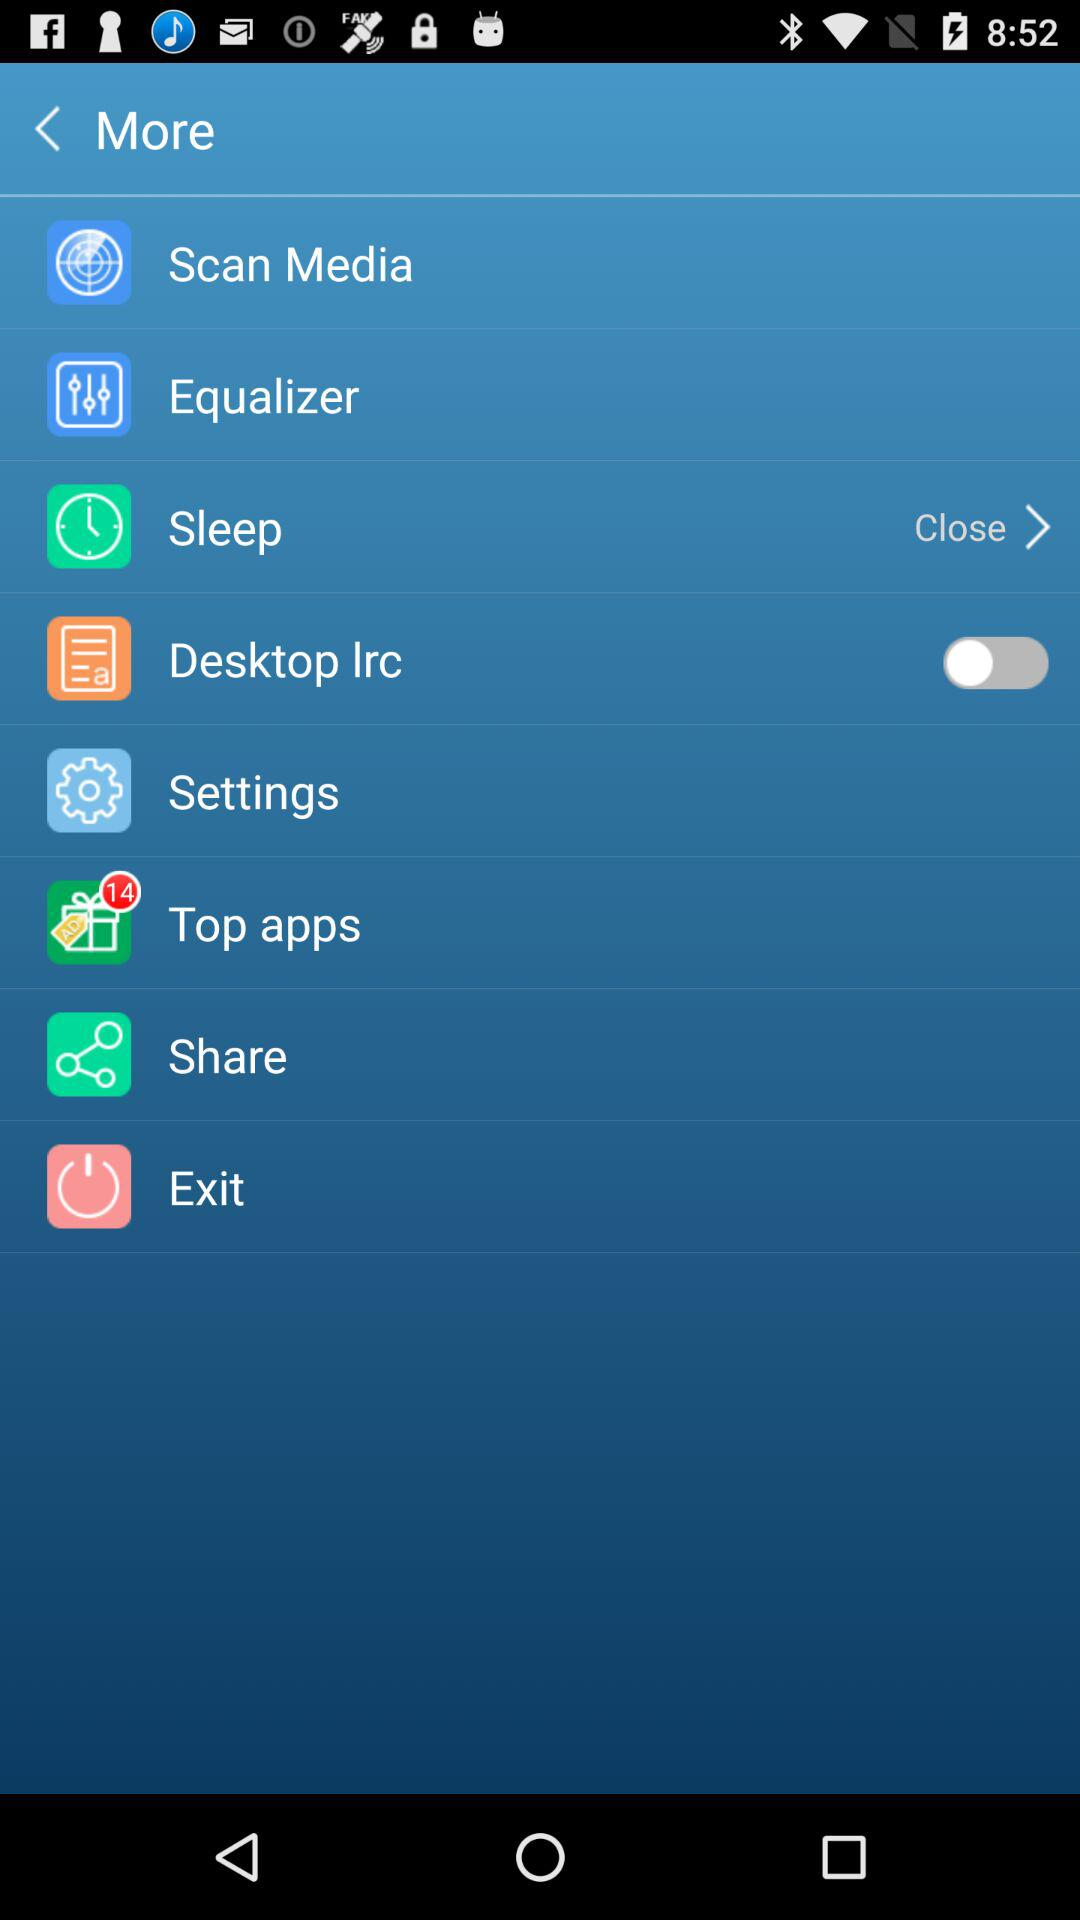What is the status of "sleep"? The status is "Close". 